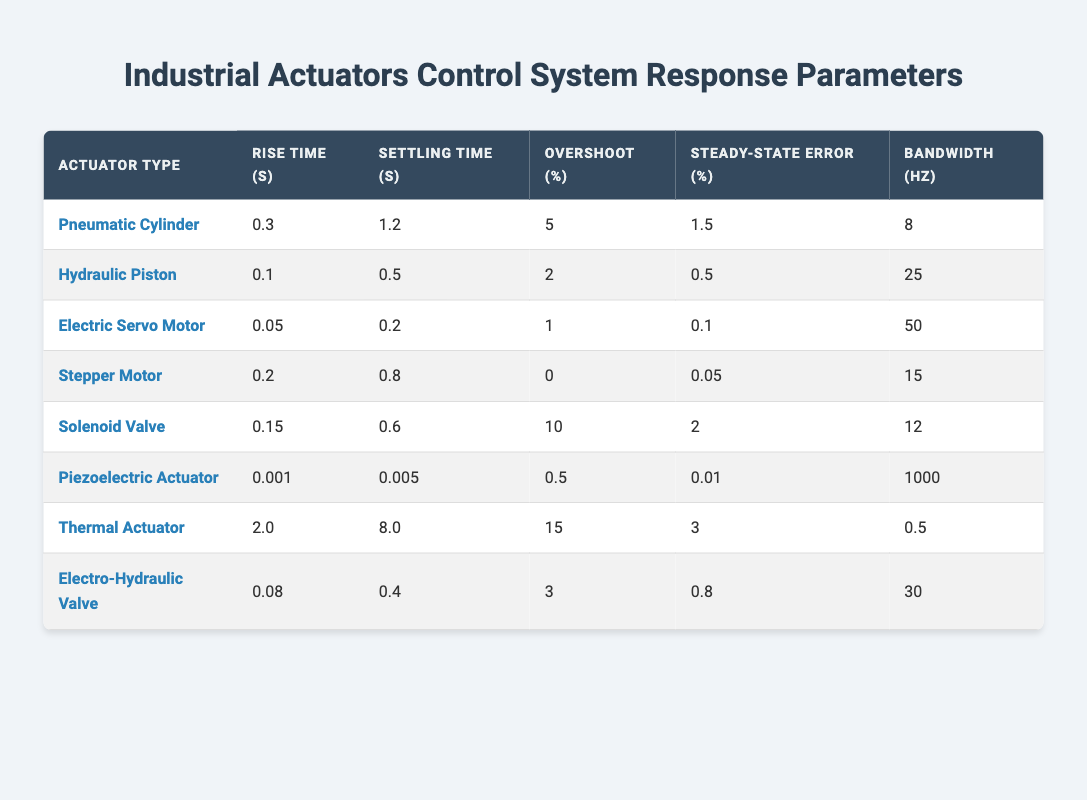What is the rise time for the Electric Servo Motor? The table shows the rise time in the column for the Electric Servo Motor. By locating the row for Electric Servo Motor, we find that the rise time is 0.05 seconds.
Answer: 0.05 Which actuator has the shortest settling time? The settling time is found in the corresponding column for all actuators. By comparing the values, the shortest settling time is 0.005 seconds for the Piezoelectric Actuator.
Answer: Piezoelectric Actuator What is the average overshoot percentage for the hydraulic and electro-hydraulic actuators? The overshoot for the Hydraulic Piston is 2% and for the Electro-Hydraulic Valve, it's 3%. Adding these gives 5%, and dividing by 2 (the number of actuators) yields an average of 2.5%.
Answer: 2.5 Does the Pneumatic Cylinder have a higher steady-state error than the Stepper Motor? From the table, the steady-state error for the Pneumatic Cylinder is 1.5% and for the Stepper Motor, it is 0.05%. Since 1.5% is greater than 0.05%, the statement is true.
Answer: Yes Which actuator type has the highest bandwidth, and what is its value? The bandwidth is listed for each actuator in the appropriate column. The highest bandwidth is 1000 Hz, which belongs to the Piezoelectric Actuator.
Answer: Piezoelectric Actuator - 1000 Hz How do the rise times of the Thermal Actuator and the Electric Servo Motor compare? The rise time of the Thermal Actuator is 2.0 seconds and that of the Electric Servo Motor is 0.05 seconds. Since 2.0 seconds is greater than 0.05 seconds, the Thermal Actuator has a longer rise time.
Answer: Thermal Actuator has a longer rise time What is the difference in settling time between the Piezoelectric Actuator and the Thermal Actuator? The settling time for the Piezoelectric Actuator is 0.005 seconds and for the Thermal Actuator it is 8.0 seconds. The difference is calculated as 8.0 - 0.005 = 7.995 seconds.
Answer: 7.995 seconds Does the Solenoid Valve have an overshoot percentage greater than 5%? The overshoot percentage for the Solenoid Valve is listed as 10%. Since 10% is greater than 5%, the statement is true.
Answer: Yes Which actuator has the highest steady-state error percentage, and what is the value? The steady-state errors for all actuators are compared, with the maximum being found in the Thermal Actuator, which has a steady-state error of 3%.
Answer: Thermal Actuator - 3% 